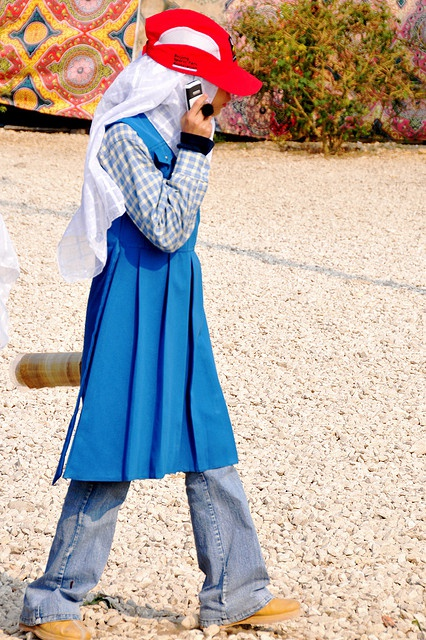Describe the objects in this image and their specific colors. I can see people in salmon, lightgray, gray, darkgray, and blue tones and cell phone in salmon, white, black, and darkgray tones in this image. 